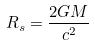<formula> <loc_0><loc_0><loc_500><loc_500>R _ { s } = \frac { 2 G M } { c ^ { 2 } }</formula> 